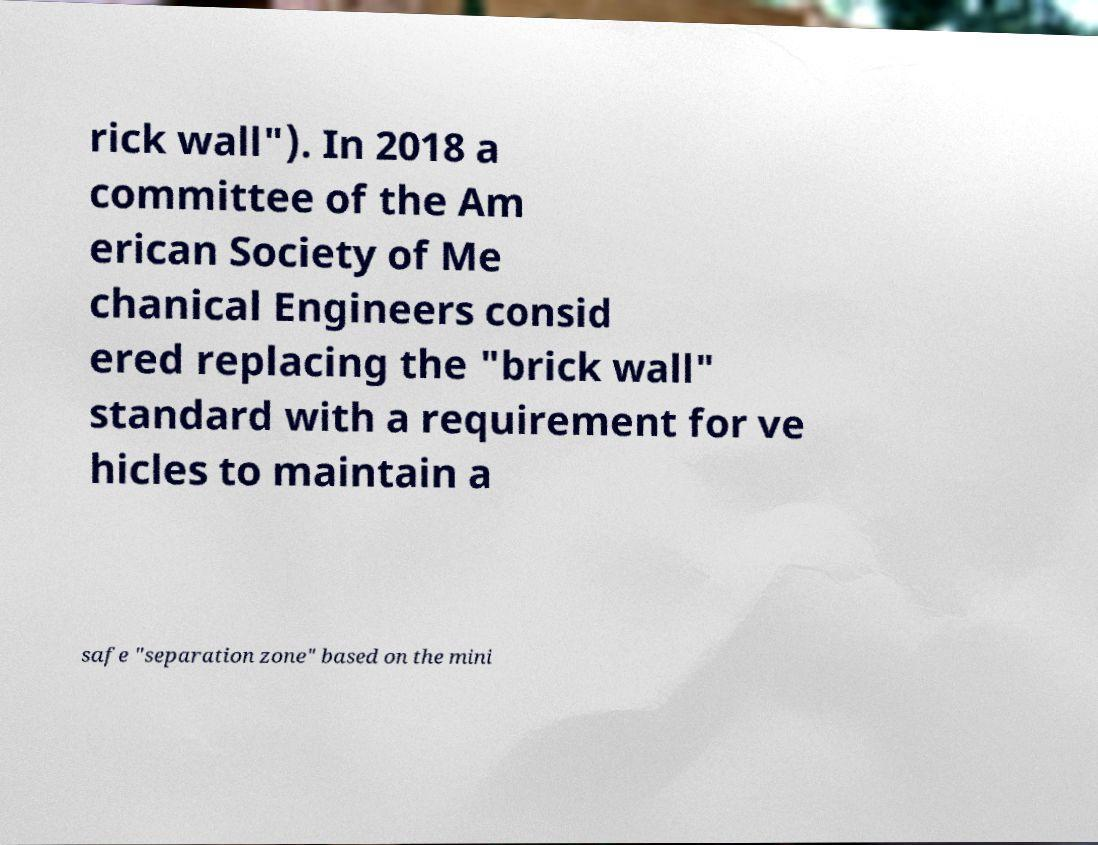What messages or text are displayed in this image? I need them in a readable, typed format. rick wall"). In 2018 a committee of the Am erican Society of Me chanical Engineers consid ered replacing the "brick wall" standard with a requirement for ve hicles to maintain a safe "separation zone" based on the mini 